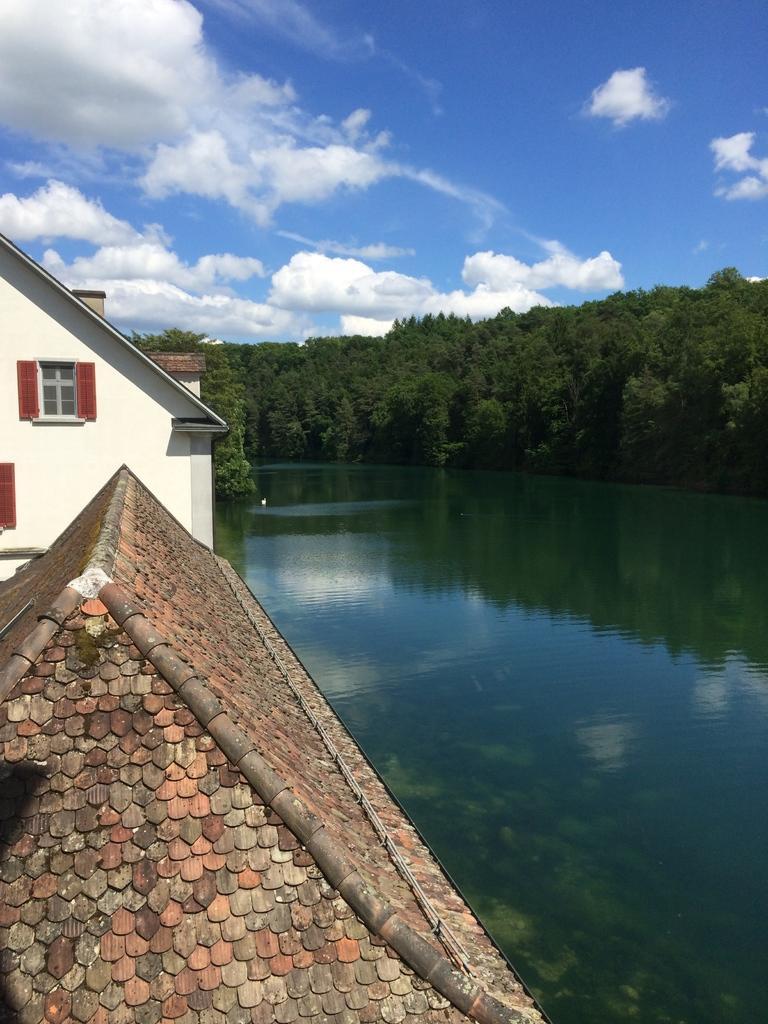Please provide a concise description of this image. In this image I can see few houses, windows, water and few green color trees. The sky is in blue and white color. 